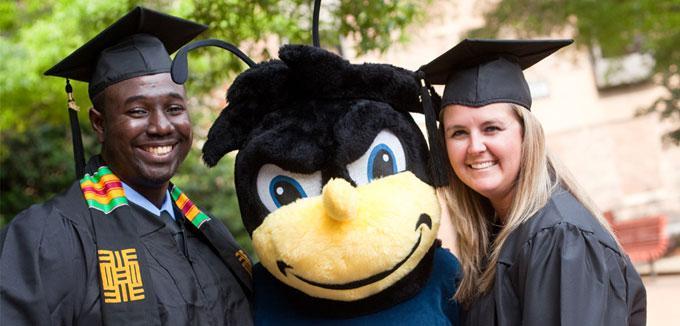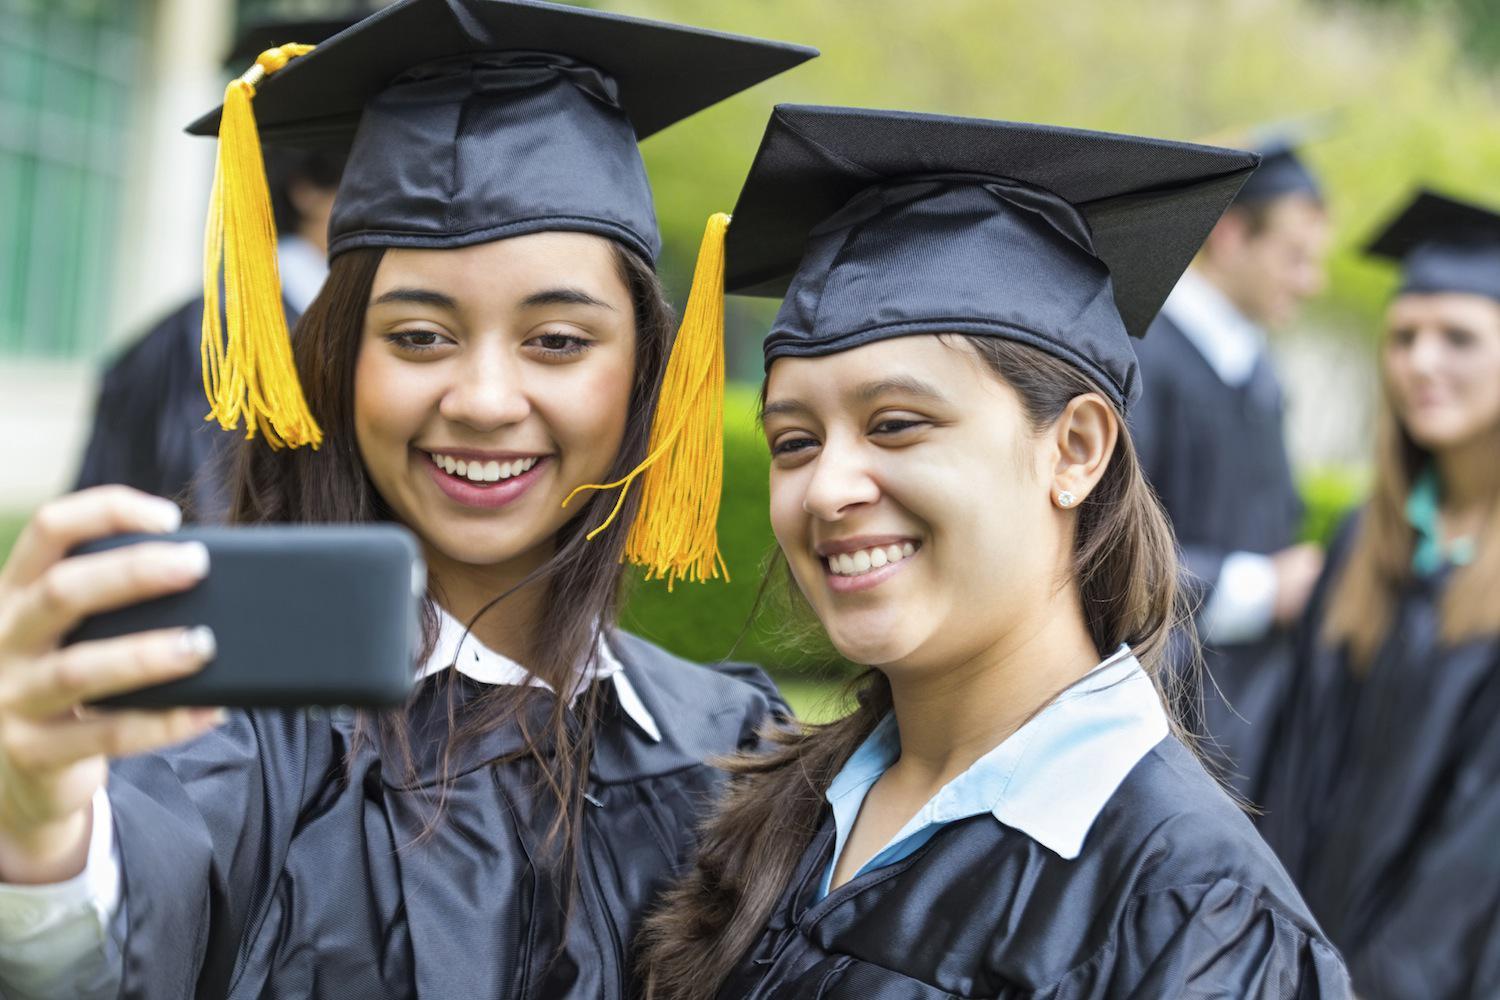The first image is the image on the left, the second image is the image on the right. Assess this claim about the two images: "Each image focuses on two smiling graduates wearing black gowns and mortarboards with a tassel hanging from each.". Correct or not? Answer yes or no. Yes. The first image is the image on the left, the second image is the image on the right. For the images shown, is this caption "An image shows a nonwhite male graduate standing on the left and a white female standing on the right." true? Answer yes or no. Yes. 